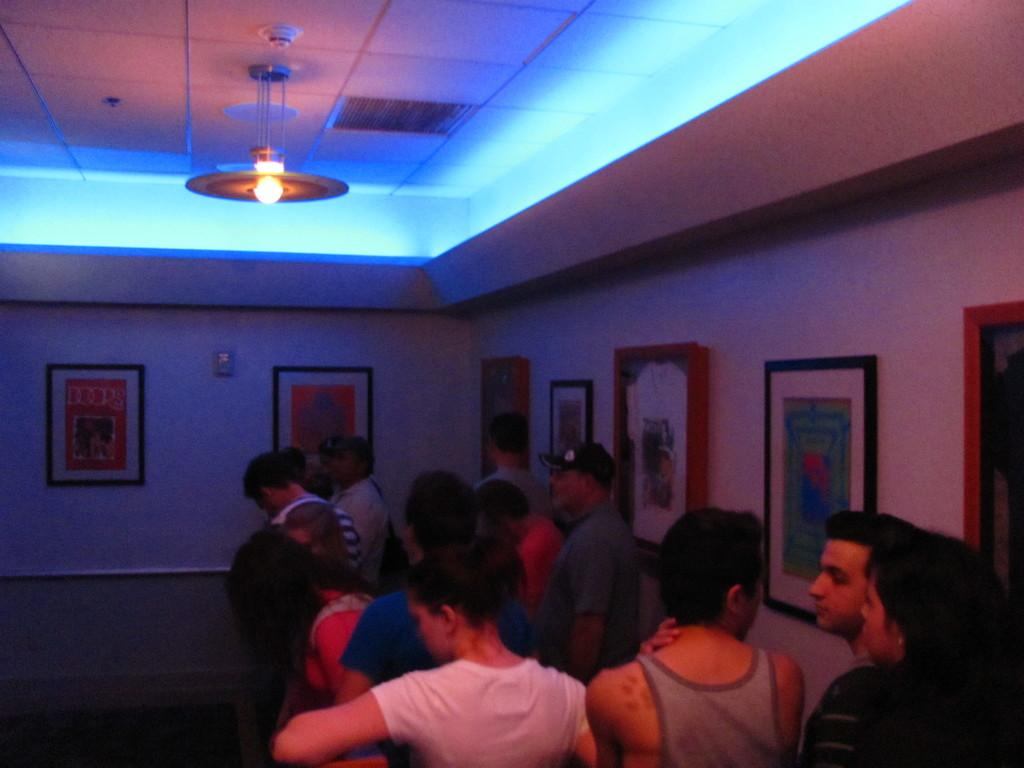What can be seen in the foreground of the image? There are people and frames on the wall in the foreground area of the image. Can you describe the lighting in the image? It appears that there is a chandelier in the image, and there is a light at the top side of the image. What type of gun is being discussed by the committee in the image? There is no mention of a gun or committee in the image; it features people and frames on the wall with a chandelier and light. 